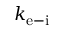<formula> <loc_0><loc_0><loc_500><loc_500>k _ { e - i }</formula> 